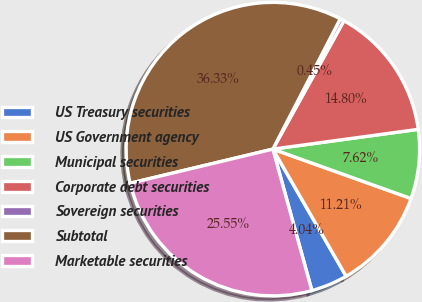<chart> <loc_0><loc_0><loc_500><loc_500><pie_chart><fcel>US Treasury securities<fcel>US Government agency<fcel>Municipal securities<fcel>Corporate debt securities<fcel>Sovereign securities<fcel>Subtotal<fcel>Marketable securities<nl><fcel>4.04%<fcel>11.21%<fcel>7.62%<fcel>14.8%<fcel>0.45%<fcel>36.33%<fcel>25.55%<nl></chart> 